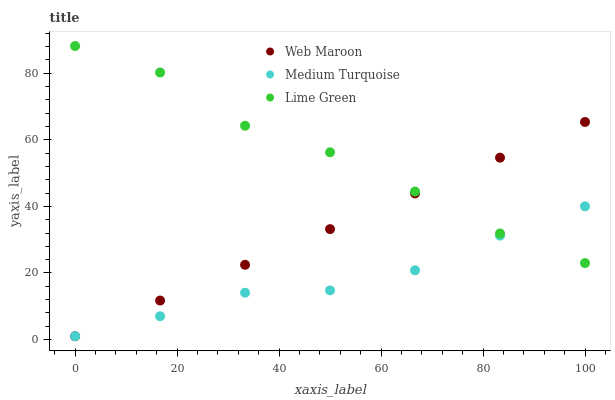Does Medium Turquoise have the minimum area under the curve?
Answer yes or no. Yes. Does Lime Green have the maximum area under the curve?
Answer yes or no. Yes. Does Web Maroon have the minimum area under the curve?
Answer yes or no. No. Does Web Maroon have the maximum area under the curve?
Answer yes or no. No. Is Web Maroon the smoothest?
Answer yes or no. Yes. Is Lime Green the roughest?
Answer yes or no. Yes. Is Medium Turquoise the smoothest?
Answer yes or no. No. Is Medium Turquoise the roughest?
Answer yes or no. No. Does Web Maroon have the lowest value?
Answer yes or no. Yes. Does Lime Green have the highest value?
Answer yes or no. Yes. Does Web Maroon have the highest value?
Answer yes or no. No. Does Web Maroon intersect Medium Turquoise?
Answer yes or no. Yes. Is Web Maroon less than Medium Turquoise?
Answer yes or no. No. Is Web Maroon greater than Medium Turquoise?
Answer yes or no. No. 